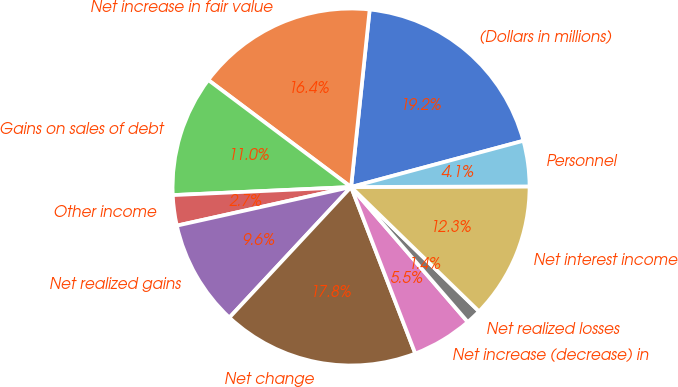<chart> <loc_0><loc_0><loc_500><loc_500><pie_chart><fcel>(Dollars in millions)<fcel>Net increase in fair value<fcel>Gains on sales of debt<fcel>Other income<fcel>Net realized gains<fcel>Net change<fcel>Net increase (decrease) in<fcel>Net realized losses<fcel>Net interest income<fcel>Personnel<nl><fcel>19.17%<fcel>16.43%<fcel>10.96%<fcel>2.75%<fcel>9.59%<fcel>17.8%<fcel>5.49%<fcel>1.38%<fcel>12.33%<fcel>4.12%<nl></chart> 